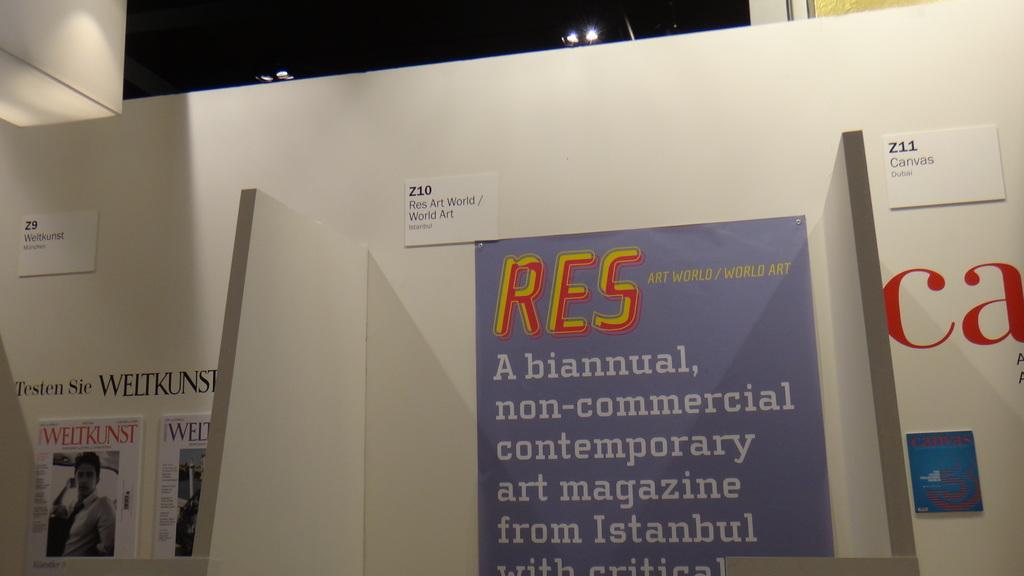Where is the art magazine from?
Offer a terse response. Istanbul. 